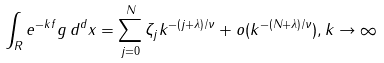<formula> <loc_0><loc_0><loc_500><loc_500>\int _ { R } e ^ { - k f } g \, d ^ { d } x = \sum _ { j = 0 } ^ { N } \zeta _ { j } k ^ { - ( j + \lambda ) / \nu } + o ( k ^ { - ( N + \lambda ) / \nu } ) , k \rightarrow \infty</formula> 